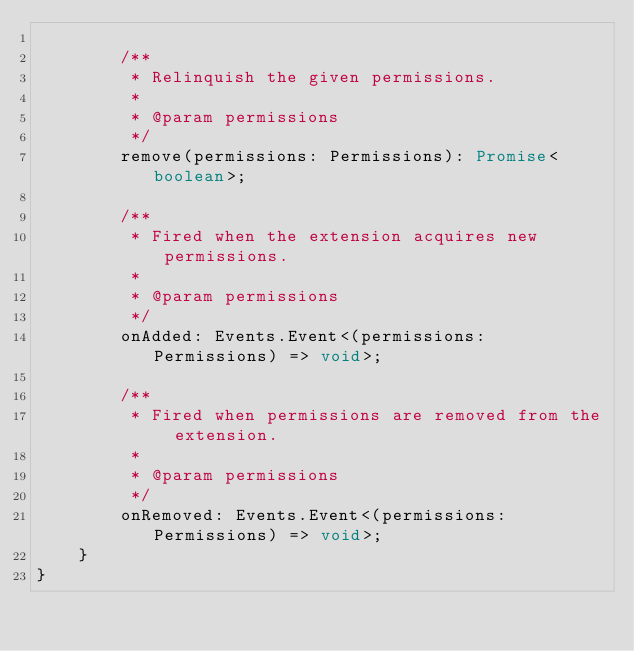Convert code to text. <code><loc_0><loc_0><loc_500><loc_500><_TypeScript_>
        /**
         * Relinquish the given permissions.
         *
         * @param permissions
         */
        remove(permissions: Permissions): Promise<boolean>;

        /**
         * Fired when the extension acquires new permissions.
         *
         * @param permissions
         */
        onAdded: Events.Event<(permissions: Permissions) => void>;

        /**
         * Fired when permissions are removed from the extension.
         *
         * @param permissions
         */
        onRemoved: Events.Event<(permissions: Permissions) => void>;
    }
}
</code> 